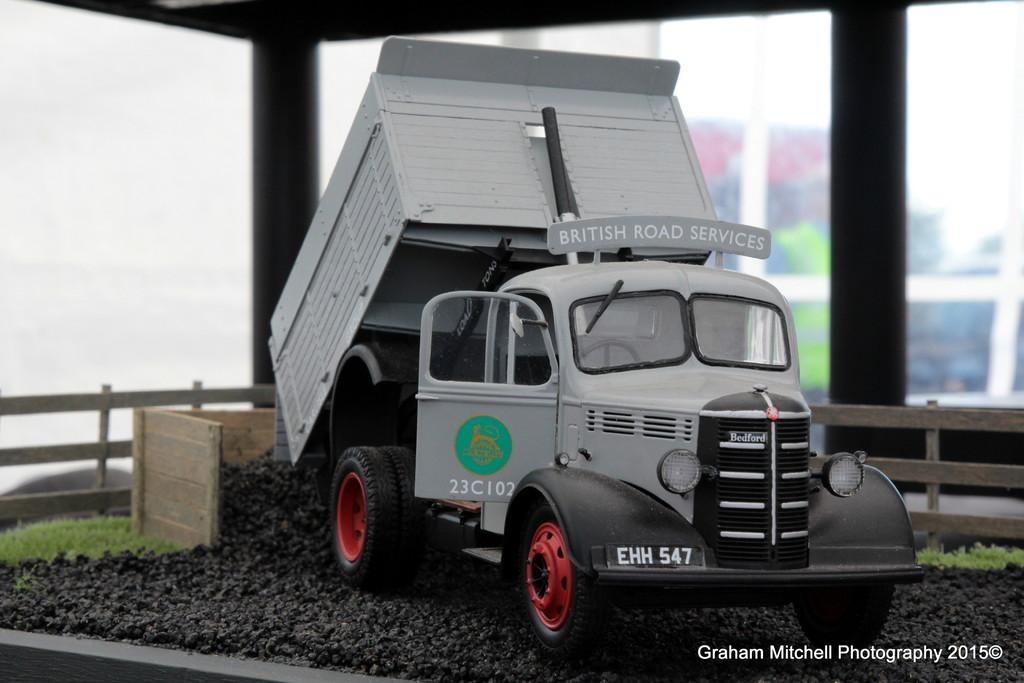What is the main subject in the center of the image? There is a truck in the center of the image. What type of fencing can be seen in the image? There is wooden fencing in the image. What type of vegetation is visible in the image? There is grass visible in the image. How many oranges are hanging from the wooden fencing in the image? There are no oranges present in the image; it features a truck and wooden fencing. What type of fowl can be seen walking on the grass in the image? There is no fowl present in the image; it only features a truck, wooden fencing, and grass. 